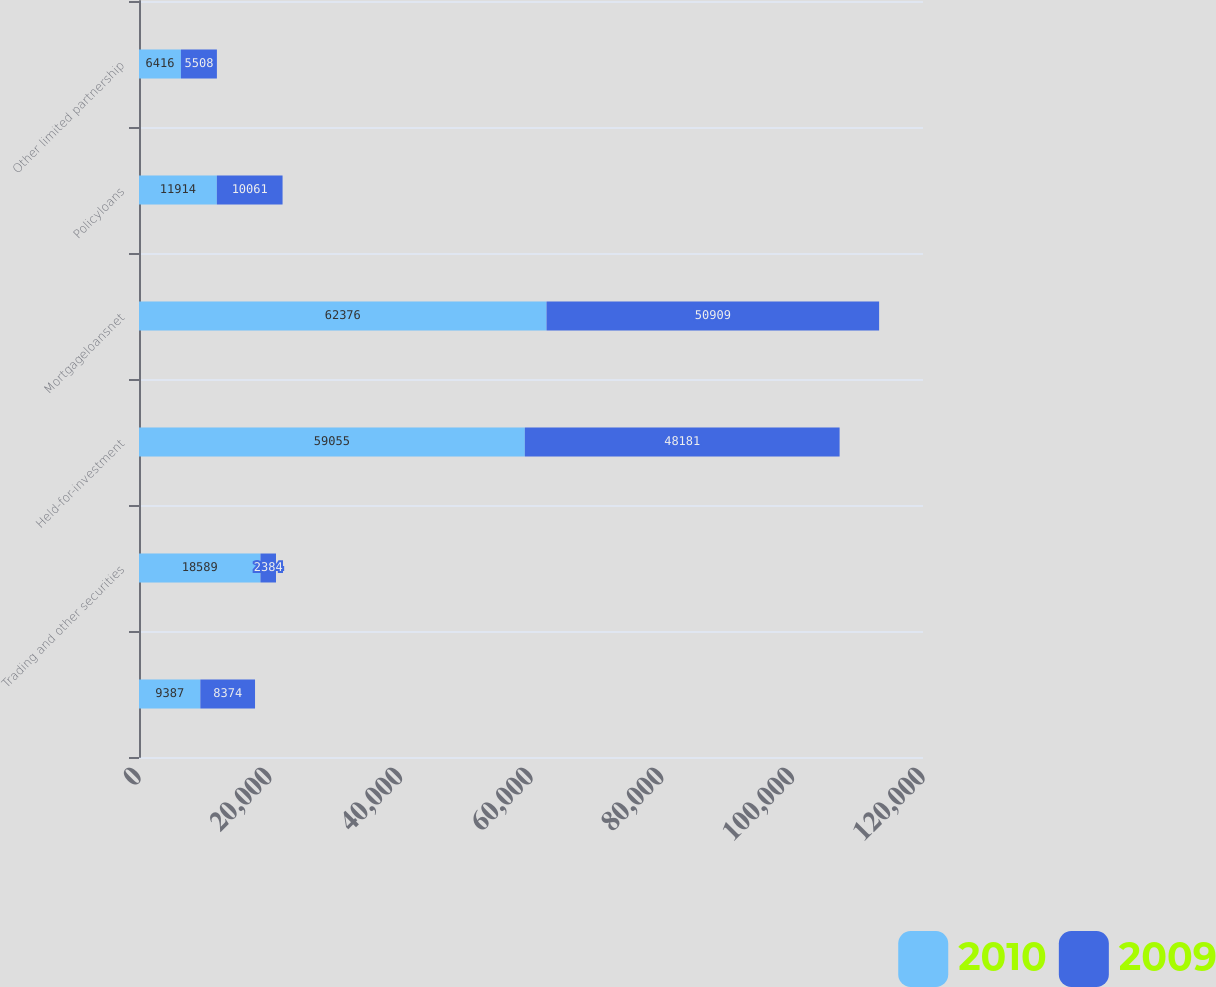<chart> <loc_0><loc_0><loc_500><loc_500><stacked_bar_chart><ecel><fcel>Unnamed: 1<fcel>Trading and other securities<fcel>Held-for-investment<fcel>Mortgageloansnet<fcel>Policyloans<fcel>Other limited partnership<nl><fcel>2010<fcel>9387<fcel>18589<fcel>59055<fcel>62376<fcel>11914<fcel>6416<nl><fcel>2009<fcel>8374<fcel>2384<fcel>48181<fcel>50909<fcel>10061<fcel>5508<nl></chart> 